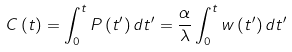Convert formula to latex. <formula><loc_0><loc_0><loc_500><loc_500>C \left ( t \right ) = \int _ { 0 } ^ { t } P \left ( t ^ { \prime } \right ) d t ^ { \prime } = \frac { \alpha } { \lambda } \int _ { 0 } ^ { t } w \left ( t ^ { \prime } \right ) d t ^ { \prime }</formula> 